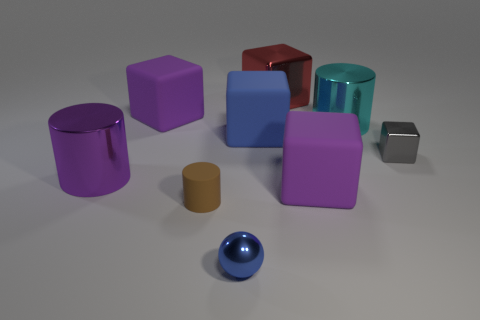Is the number of purple rubber things in front of the cyan metal cylinder less than the number of big green metal cylinders? No, there are two purple rubber objects in front of the cyan metal cylinder, which is equal to the number of big green metal cylinders present. 